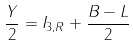Convert formula to latex. <formula><loc_0><loc_0><loc_500><loc_500>\frac { Y } { 2 } = I _ { 3 , R } + \frac { B - L } { 2 }</formula> 